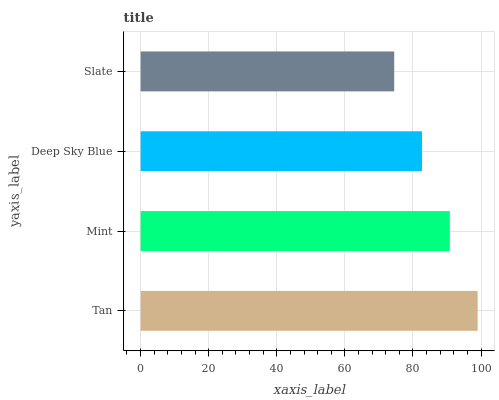Is Slate the minimum?
Answer yes or no. Yes. Is Tan the maximum?
Answer yes or no. Yes. Is Mint the minimum?
Answer yes or no. No. Is Mint the maximum?
Answer yes or no. No. Is Tan greater than Mint?
Answer yes or no. Yes. Is Mint less than Tan?
Answer yes or no. Yes. Is Mint greater than Tan?
Answer yes or no. No. Is Tan less than Mint?
Answer yes or no. No. Is Mint the high median?
Answer yes or no. Yes. Is Deep Sky Blue the low median?
Answer yes or no. Yes. Is Deep Sky Blue the high median?
Answer yes or no. No. Is Slate the low median?
Answer yes or no. No. 